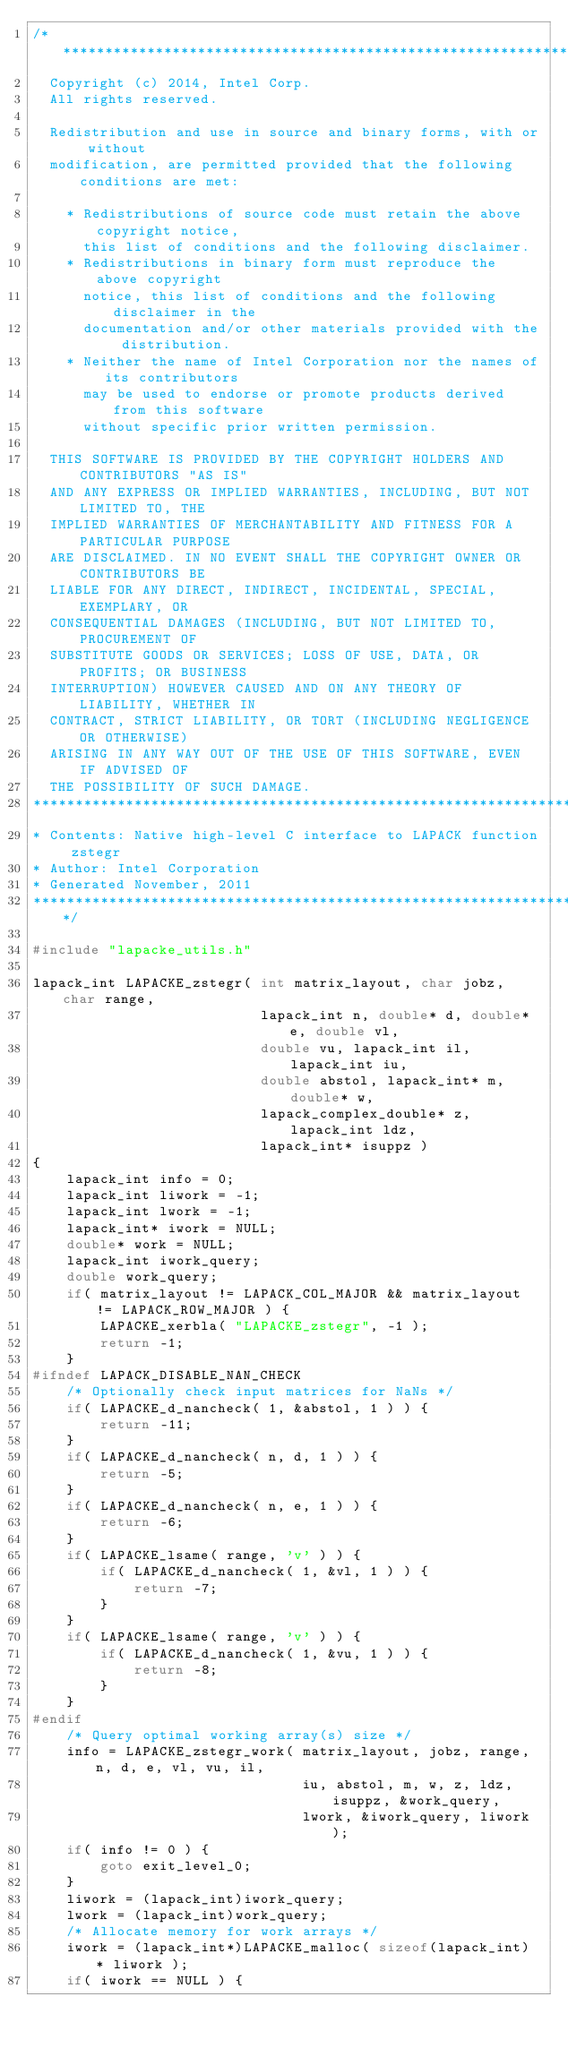Convert code to text. <code><loc_0><loc_0><loc_500><loc_500><_C_>/*****************************************************************************
  Copyright (c) 2014, Intel Corp.
  All rights reserved.

  Redistribution and use in source and binary forms, with or without
  modification, are permitted provided that the following conditions are met:

    * Redistributions of source code must retain the above copyright notice,
      this list of conditions and the following disclaimer.
    * Redistributions in binary form must reproduce the above copyright
      notice, this list of conditions and the following disclaimer in the
      documentation and/or other materials provided with the distribution.
    * Neither the name of Intel Corporation nor the names of its contributors
      may be used to endorse or promote products derived from this software
      without specific prior written permission.

  THIS SOFTWARE IS PROVIDED BY THE COPYRIGHT HOLDERS AND CONTRIBUTORS "AS IS"
  AND ANY EXPRESS OR IMPLIED WARRANTIES, INCLUDING, BUT NOT LIMITED TO, THE
  IMPLIED WARRANTIES OF MERCHANTABILITY AND FITNESS FOR A PARTICULAR PURPOSE
  ARE DISCLAIMED. IN NO EVENT SHALL THE COPYRIGHT OWNER OR CONTRIBUTORS BE
  LIABLE FOR ANY DIRECT, INDIRECT, INCIDENTAL, SPECIAL, EXEMPLARY, OR
  CONSEQUENTIAL DAMAGES (INCLUDING, BUT NOT LIMITED TO, PROCUREMENT OF
  SUBSTITUTE GOODS OR SERVICES; LOSS OF USE, DATA, OR PROFITS; OR BUSINESS
  INTERRUPTION) HOWEVER CAUSED AND ON ANY THEORY OF LIABILITY, WHETHER IN
  CONTRACT, STRICT LIABILITY, OR TORT (INCLUDING NEGLIGENCE OR OTHERWISE)
  ARISING IN ANY WAY OUT OF THE USE OF THIS SOFTWARE, EVEN IF ADVISED OF
  THE POSSIBILITY OF SUCH DAMAGE.
*****************************************************************************
* Contents: Native high-level C interface to LAPACK function zstegr
* Author: Intel Corporation
* Generated November, 2011
*****************************************************************************/

#include "lapacke_utils.h"

lapack_int LAPACKE_zstegr( int matrix_layout, char jobz, char range,
                           lapack_int n, double* d, double* e, double vl,
                           double vu, lapack_int il, lapack_int iu,
                           double abstol, lapack_int* m, double* w,
                           lapack_complex_double* z, lapack_int ldz,
                           lapack_int* isuppz )
{
    lapack_int info = 0;
    lapack_int liwork = -1;
    lapack_int lwork = -1;
    lapack_int* iwork = NULL;
    double* work = NULL;
    lapack_int iwork_query;
    double work_query;
    if( matrix_layout != LAPACK_COL_MAJOR && matrix_layout != LAPACK_ROW_MAJOR ) {
        LAPACKE_xerbla( "LAPACKE_zstegr", -1 );
        return -1;
    }
#ifndef LAPACK_DISABLE_NAN_CHECK
    /* Optionally check input matrices for NaNs */
    if( LAPACKE_d_nancheck( 1, &abstol, 1 ) ) {
        return -11;
    }
    if( LAPACKE_d_nancheck( n, d, 1 ) ) {
        return -5;
    }
    if( LAPACKE_d_nancheck( n, e, 1 ) ) {
        return -6;
    }
    if( LAPACKE_lsame( range, 'v' ) ) {
        if( LAPACKE_d_nancheck( 1, &vl, 1 ) ) {
            return -7;
        }
    }
    if( LAPACKE_lsame( range, 'v' ) ) {
        if( LAPACKE_d_nancheck( 1, &vu, 1 ) ) {
            return -8;
        }
    }
#endif
    /* Query optimal working array(s) size */
    info = LAPACKE_zstegr_work( matrix_layout, jobz, range, n, d, e, vl, vu, il,
                                iu, abstol, m, w, z, ldz, isuppz, &work_query,
                                lwork, &iwork_query, liwork );
    if( info != 0 ) {
        goto exit_level_0;
    }
    liwork = (lapack_int)iwork_query;
    lwork = (lapack_int)work_query;
    /* Allocate memory for work arrays */
    iwork = (lapack_int*)LAPACKE_malloc( sizeof(lapack_int) * liwork );
    if( iwork == NULL ) {</code> 